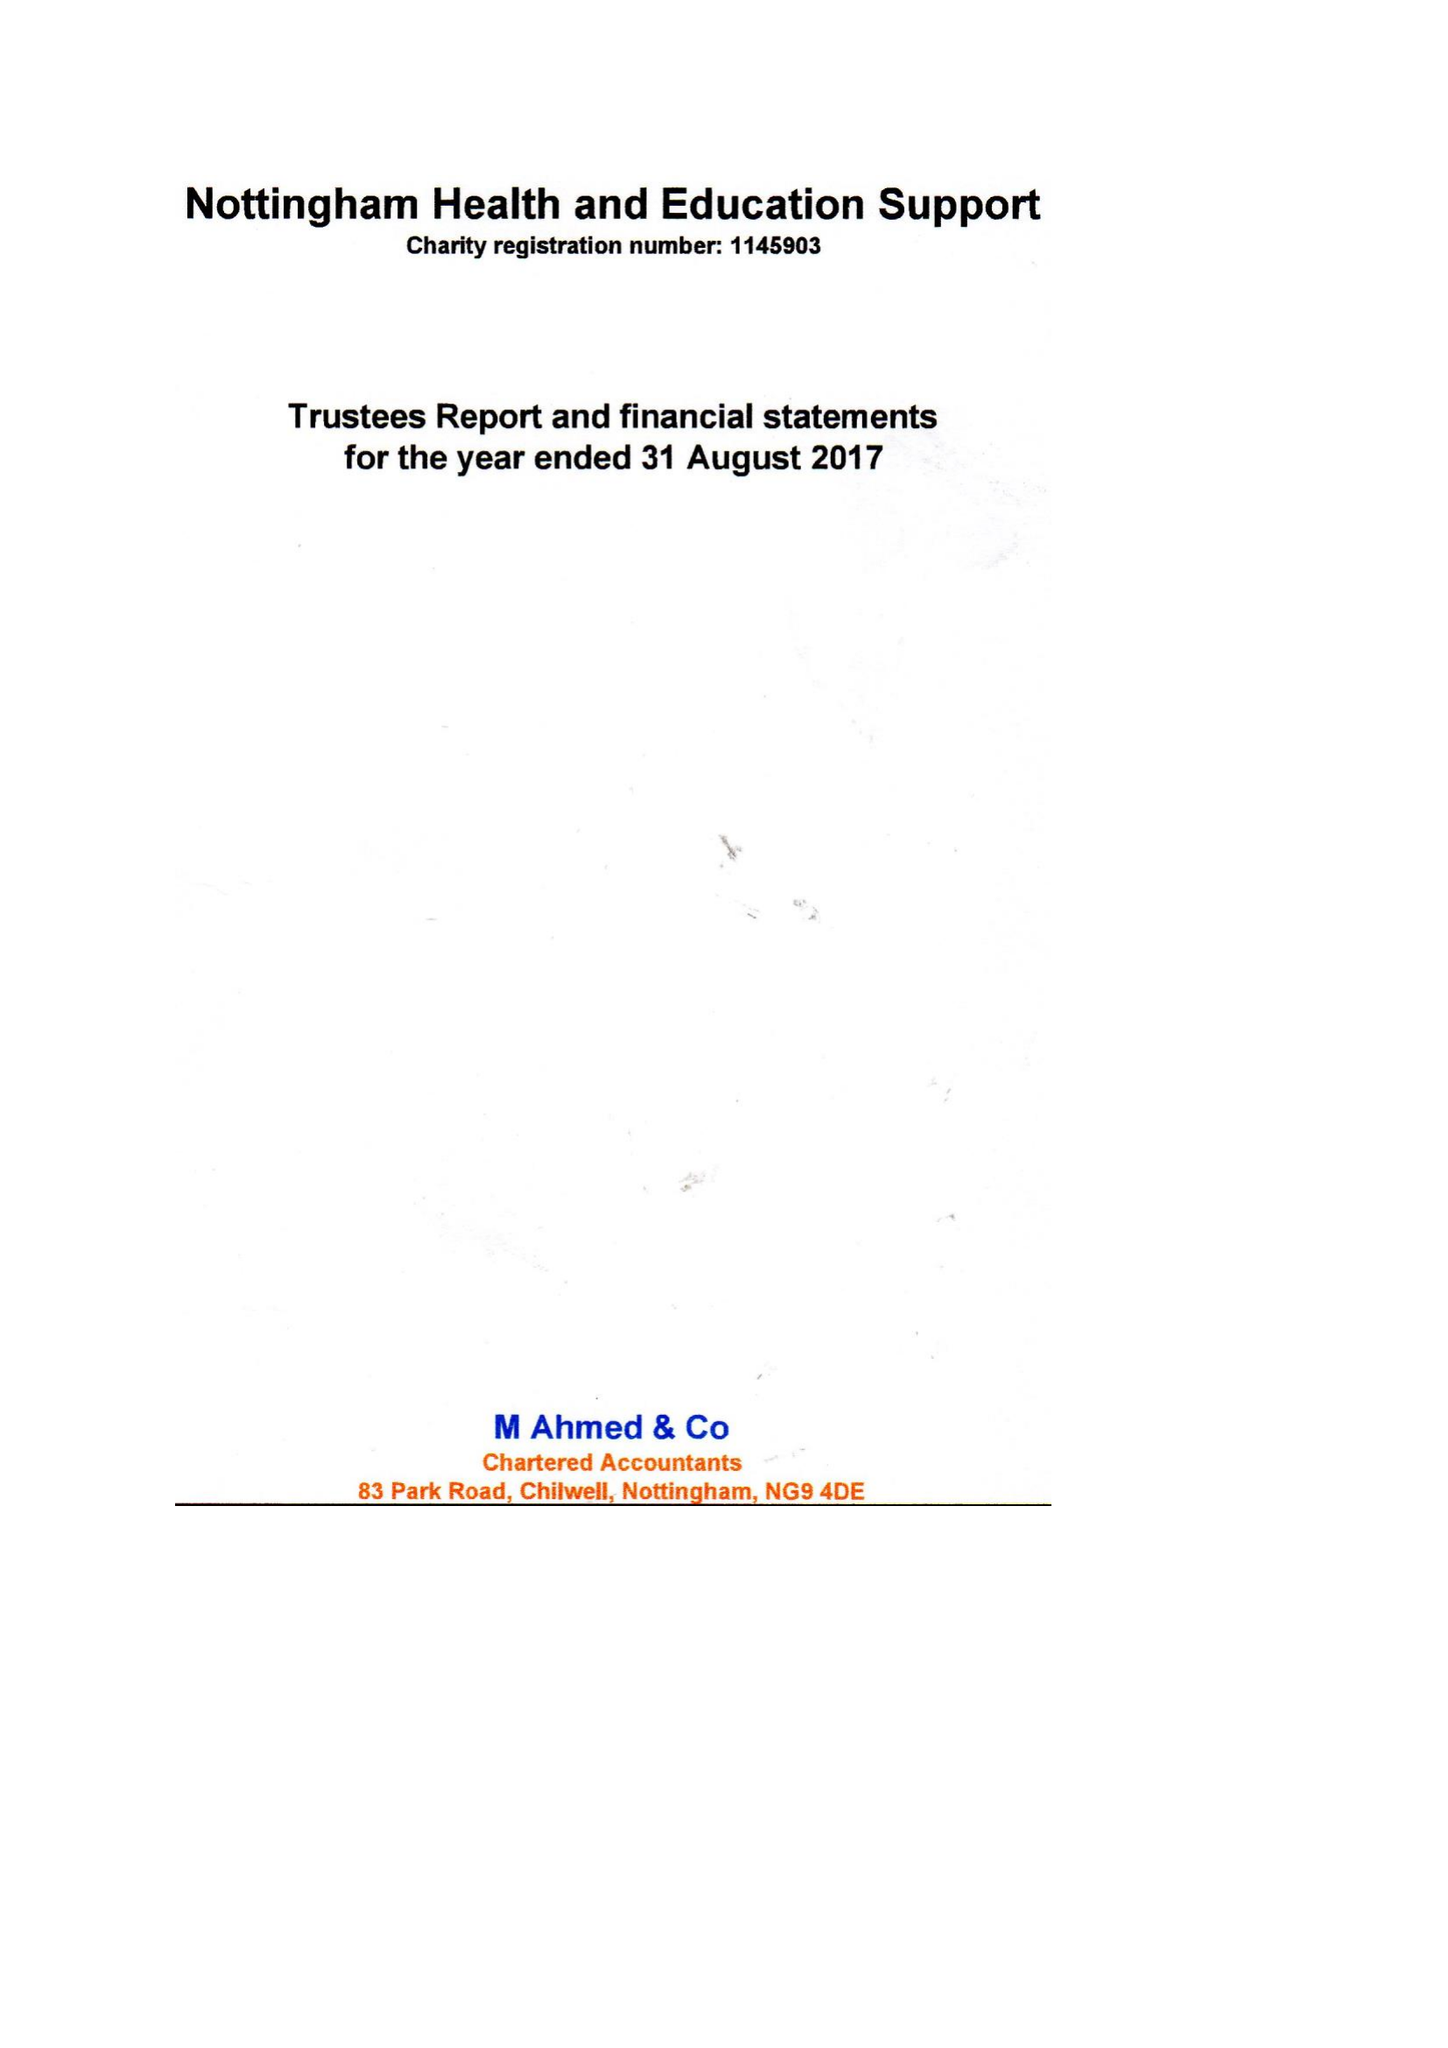What is the value for the report_date?
Answer the question using a single word or phrase. 2017-08-31 